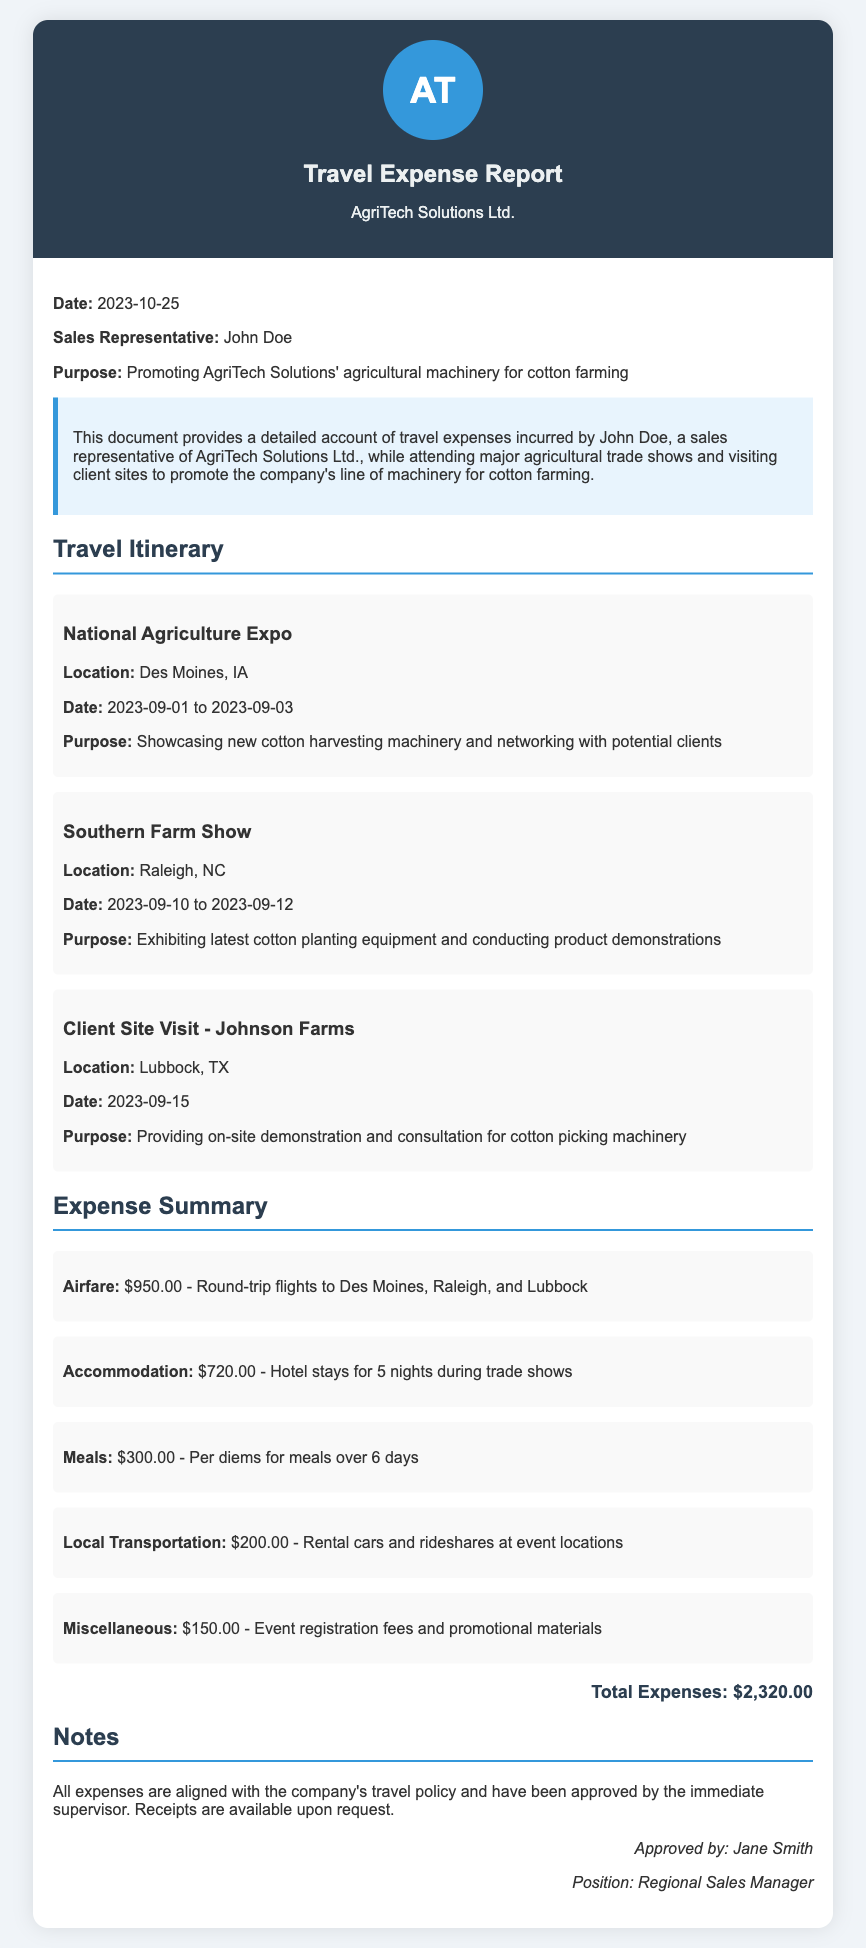What is the name of the sales representative? The document clearly states the name of the sales representative as John Doe.
Answer: John Doe What is the total amount of expenses reported? The total expenses are listed in the document, specifically as $2,320.00.
Answer: $2,320.00 When did the National Agriculture Expo take place? The dates for the National Agriculture Expo are provided in the document, which are 2023-09-01 to 2023-09-03.
Answer: 2023-09-01 to 2023-09-03 What is the purpose of the site visit to Johnson Farms? The document specifies the purpose as providing on-site demonstration and consultation for cotton picking machinery.
Answer: Providing on-site demonstration and consultation for cotton picking machinery How much was spent on meals during the trip? The total amount reported for meals is found in the expense summary, specifically $300.00 for per diems.
Answer: $300.00 Who approved the travel expense report? The report indicates that Jane Smith approved the expenses, as mentioned in the approval section.
Answer: Jane Smith What type of events were attended according to the itinerary? The itinerary includes agricultural trade shows and client site visits as the types of events attended.
Answer: Agricultural trade shows and client site visits What was the location of the Southern Farm Show? The document mentions the Southern Farm Show took place in Raleigh, NC.
Answer: Raleigh, NC How many nights of accommodation were covered in the expenses? The document states there were hotel stays for 5 nights during trade shows.
Answer: 5 nights 